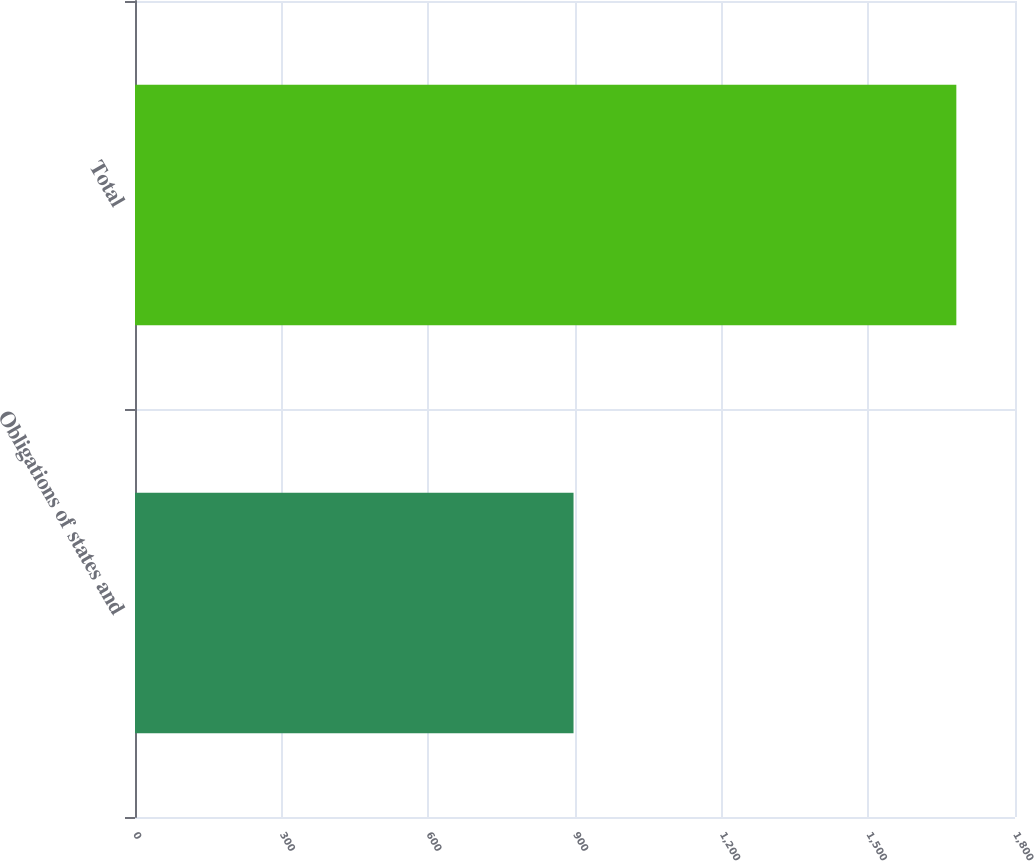<chart> <loc_0><loc_0><loc_500><loc_500><bar_chart><fcel>Obligations of states and<fcel>Total<nl><fcel>897<fcel>1680<nl></chart> 